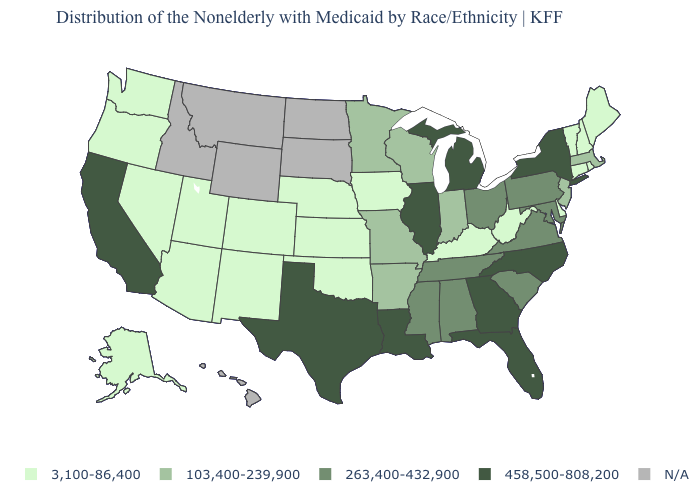Name the states that have a value in the range 458,500-808,200?
Quick response, please. California, Florida, Georgia, Illinois, Louisiana, Michigan, New York, North Carolina, Texas. What is the value of Washington?
Concise answer only. 3,100-86,400. What is the value of South Carolina?
Keep it brief. 263,400-432,900. Name the states that have a value in the range 103,400-239,900?
Be succinct. Arkansas, Indiana, Massachusetts, Minnesota, Missouri, New Jersey, Wisconsin. Does California have the lowest value in the West?
Short answer required. No. Which states hav the highest value in the MidWest?
Quick response, please. Illinois, Michigan. Is the legend a continuous bar?
Be succinct. No. Which states have the lowest value in the MidWest?
Give a very brief answer. Iowa, Kansas, Nebraska. Among the states that border Nebraska , which have the highest value?
Concise answer only. Missouri. What is the value of Arizona?
Answer briefly. 3,100-86,400. What is the lowest value in states that border New Mexico?
Quick response, please. 3,100-86,400. Does Maine have the lowest value in the Northeast?
Quick response, please. Yes. What is the value of Idaho?
Keep it brief. N/A. Does Maryland have the lowest value in the USA?
Keep it brief. No. 